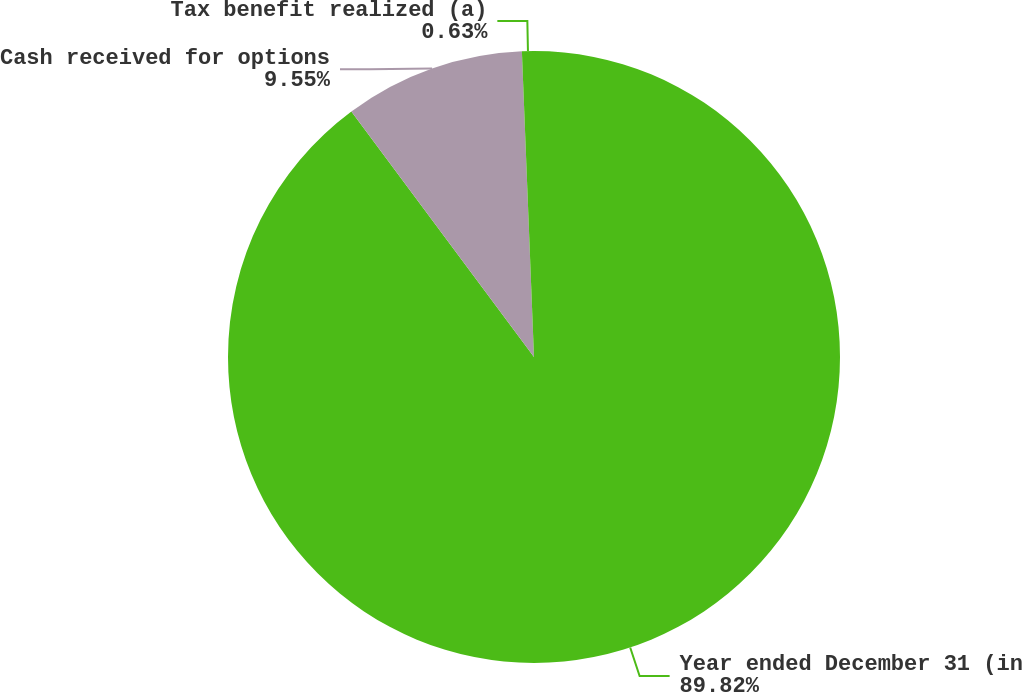Convert chart. <chart><loc_0><loc_0><loc_500><loc_500><pie_chart><fcel>Year ended December 31 (in<fcel>Cash received for options<fcel>Tax benefit realized (a)<nl><fcel>89.83%<fcel>9.55%<fcel>0.63%<nl></chart> 